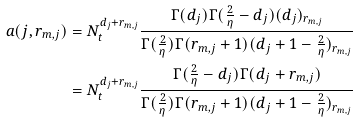<formula> <loc_0><loc_0><loc_500><loc_500>a ( j , r _ { m , j } ) & = N _ { t } ^ { d _ { j } + r _ { m , j } } \frac { \Gamma ( d _ { j } ) \Gamma ( \frac { 2 } { \eta } - d _ { j } ) ( d _ { j } ) _ { r _ { m , j } } } { \Gamma ( \frac { 2 } { \eta } ) \Gamma ( r _ { m , j } + 1 ) ( d _ { j } + 1 - \frac { 2 } { \eta } ) _ { r _ { m , j } } } \\ & = N _ { t } ^ { d _ { j } + r _ { m , j } } \frac { \Gamma ( \frac { 2 } { \eta } - d _ { j } ) \Gamma ( d _ { j } + r _ { m , j } ) } { \Gamma ( \frac { 2 } { \eta } ) \Gamma ( r _ { m , j } + 1 ) ( d _ { j } + 1 - \frac { 2 } { \eta } ) _ { r _ { m , j } } }</formula> 